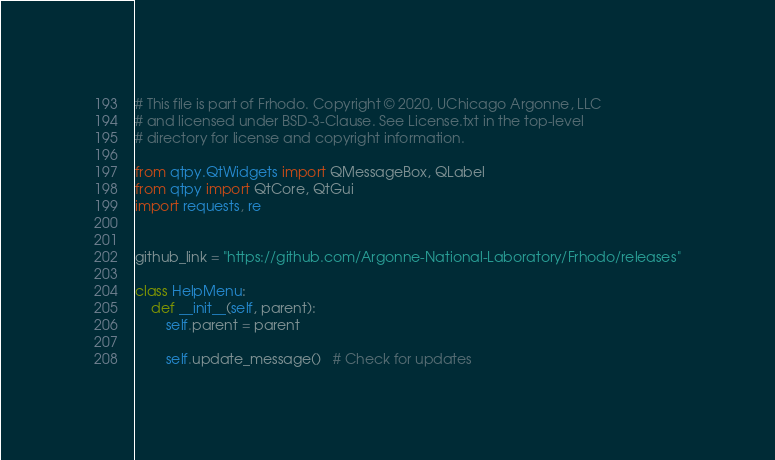Convert code to text. <code><loc_0><loc_0><loc_500><loc_500><_Python_># This file is part of Frhodo. Copyright © 2020, UChicago Argonne, LLC
# and licensed under BSD-3-Clause. See License.txt in the top-level 
# directory for license and copyright information.

from qtpy.QtWidgets import QMessageBox, QLabel
from qtpy import QtCore, QtGui
import requests, re


github_link = "https://github.com/Argonne-National-Laboratory/Frhodo/releases"

class HelpMenu:
    def __init__(self, parent):
        self.parent = parent

        self.update_message()   # Check for updates
</code> 